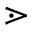Convert formula to latex. <formula><loc_0><loc_0><loc_500><loc_500>\gtrdot</formula> 